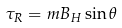<formula> <loc_0><loc_0><loc_500><loc_500>\tau _ { R } = m B _ { H } \sin \theta</formula> 